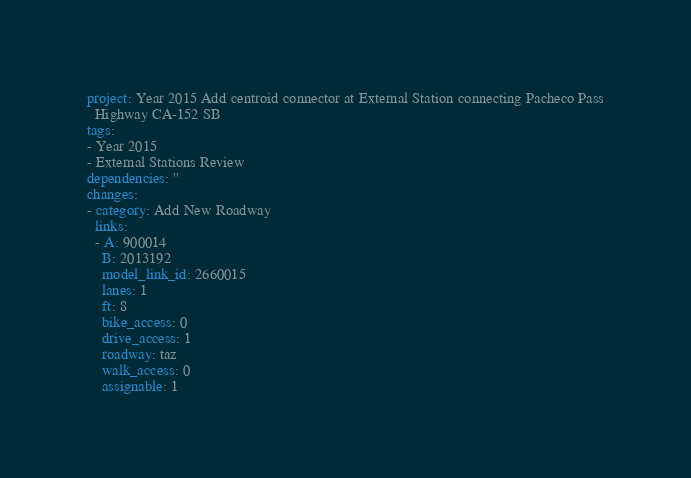Convert code to text. <code><loc_0><loc_0><loc_500><loc_500><_YAML_>project: Year 2015 Add centroid connector at External Station connecting Pacheco Pass
  Highway CA-152 SB
tags:
- Year 2015
- External Stations Review
dependencies: ''
changes:
- category: Add New Roadway
  links:
  - A: 900014
    B: 2013192
    model_link_id: 2660015
    lanes: 1
    ft: 8
    bike_access: 0
    drive_access: 1
    roadway: taz
    walk_access: 0
    assignable: 1
</code> 